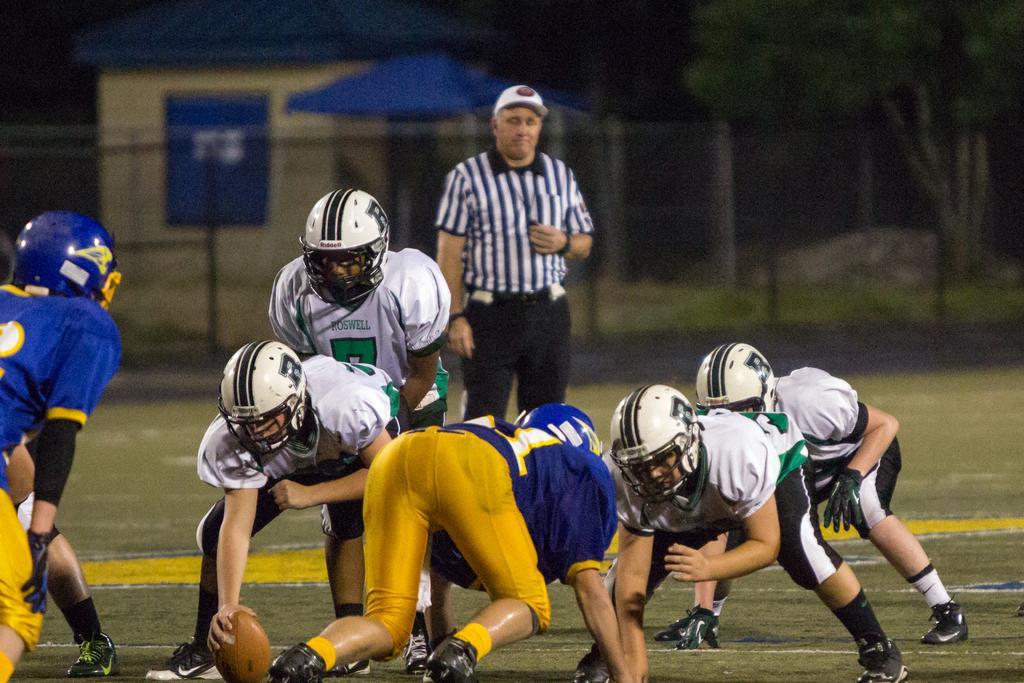Can you describe this image briefly? In the foreground of the picture we can see people playing rugby. In the middle we can see a referee. The background is blurred. In the background we can see fencing, tree and other objects. 